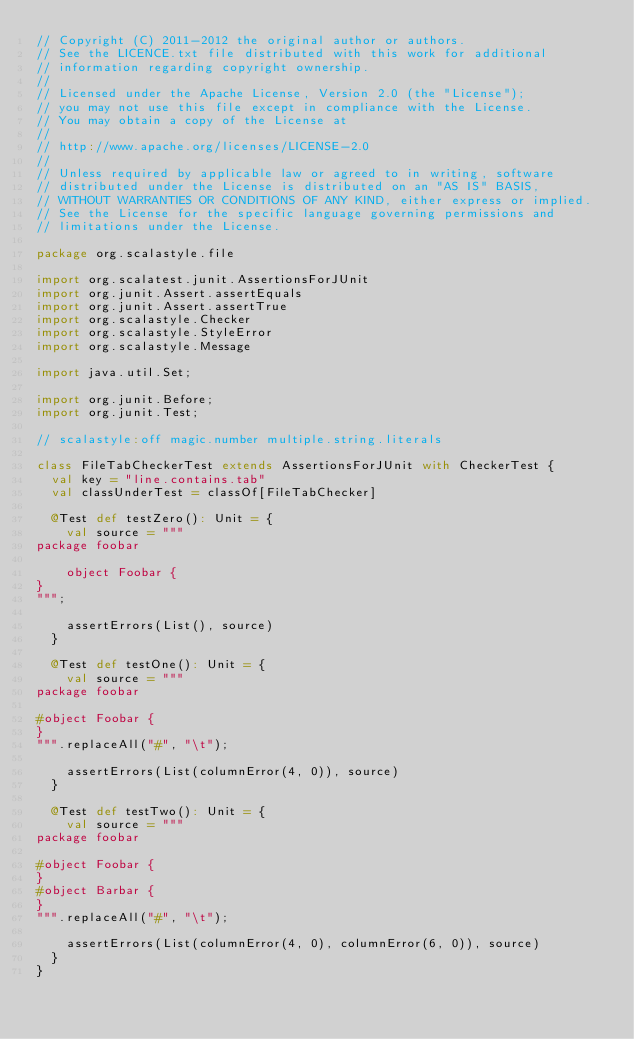<code> <loc_0><loc_0><loc_500><loc_500><_Scala_>// Copyright (C) 2011-2012 the original author or authors.
// See the LICENCE.txt file distributed with this work for additional
// information regarding copyright ownership.
//
// Licensed under the Apache License, Version 2.0 (the "License");
// you may not use this file except in compliance with the License.
// You may obtain a copy of the License at
//
// http://www.apache.org/licenses/LICENSE-2.0
//
// Unless required by applicable law or agreed to in writing, software
// distributed under the License is distributed on an "AS IS" BASIS,
// WITHOUT WARRANTIES OR CONDITIONS OF ANY KIND, either express or implied.
// See the License for the specific language governing permissions and
// limitations under the License.

package org.scalastyle.file

import org.scalatest.junit.AssertionsForJUnit
import org.junit.Assert.assertEquals
import org.junit.Assert.assertTrue
import org.scalastyle.Checker
import org.scalastyle.StyleError
import org.scalastyle.Message

import java.util.Set;

import org.junit.Before;
import org.junit.Test;

// scalastyle:off magic.number multiple.string.literals

class FileTabCheckerTest extends AssertionsForJUnit with CheckerTest {
  val key = "line.contains.tab"
  val classUnderTest = classOf[FileTabChecker]

  @Test def testZero(): Unit = {
    val source = """
package foobar

    object Foobar {
}
""";

    assertErrors(List(), source)
  }

  @Test def testOne(): Unit = {
    val source = """
package foobar

#object Foobar {
}
""".replaceAll("#", "\t");

    assertErrors(List(columnError(4, 0)), source)
  }

  @Test def testTwo(): Unit = {
    val source = """
package foobar

#object Foobar {
}
#object Barbar {
}
""".replaceAll("#", "\t");

    assertErrors(List(columnError(4, 0), columnError(6, 0)), source)
  }
}
</code> 